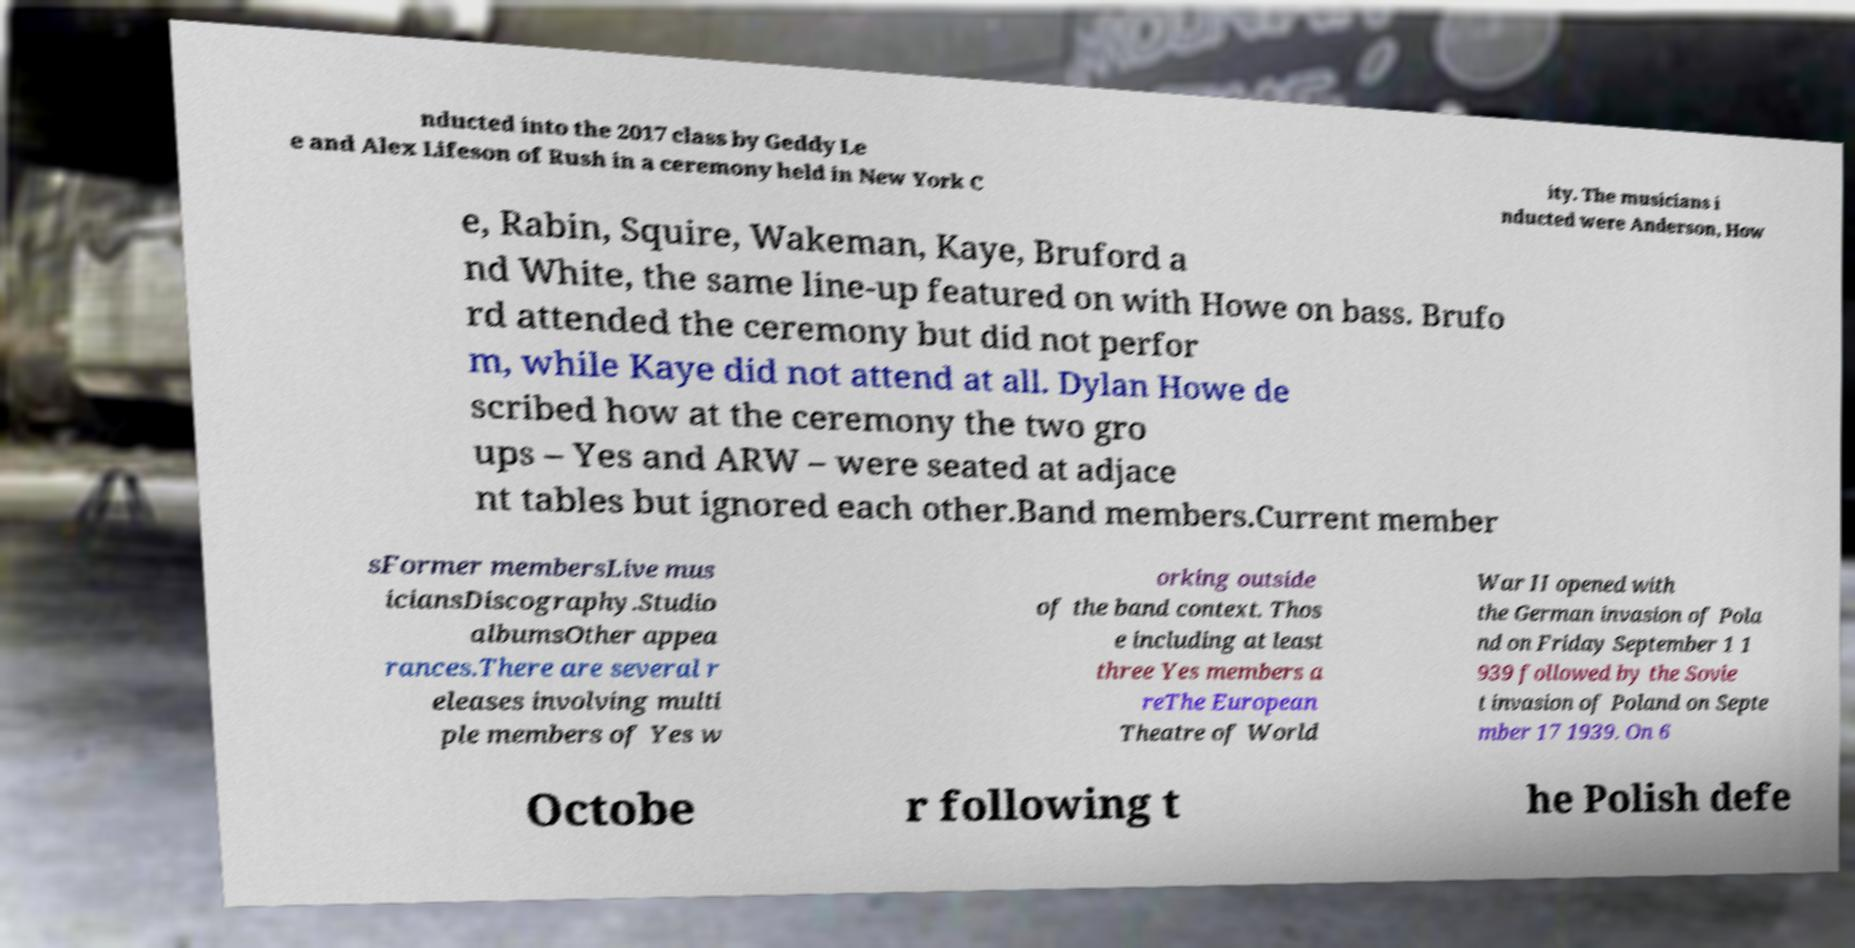Could you assist in decoding the text presented in this image and type it out clearly? nducted into the 2017 class by Geddy Le e and Alex Lifeson of Rush in a ceremony held in New York C ity. The musicians i nducted were Anderson, How e, Rabin, Squire, Wakeman, Kaye, Bruford a nd White, the same line-up featured on with Howe on bass. Brufo rd attended the ceremony but did not perfor m, while Kaye did not attend at all. Dylan Howe de scribed how at the ceremony the two gro ups – Yes and ARW – were seated at adjace nt tables but ignored each other.Band members.Current member sFormer membersLive mus iciansDiscography.Studio albumsOther appea rances.There are several r eleases involving multi ple members of Yes w orking outside of the band context. Thos e including at least three Yes members a reThe European Theatre of World War II opened with the German invasion of Pola nd on Friday September 1 1 939 followed by the Sovie t invasion of Poland on Septe mber 17 1939. On 6 Octobe r following t he Polish defe 